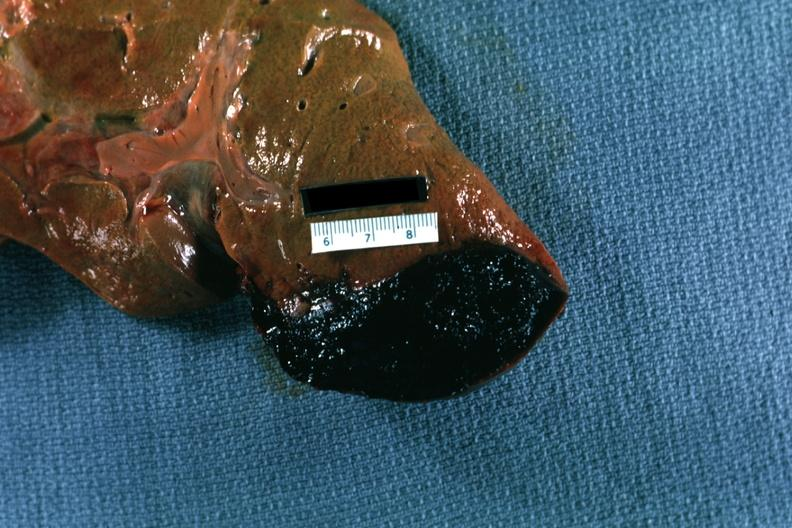what is present?
Answer the question using a single word or phrase. Liver 